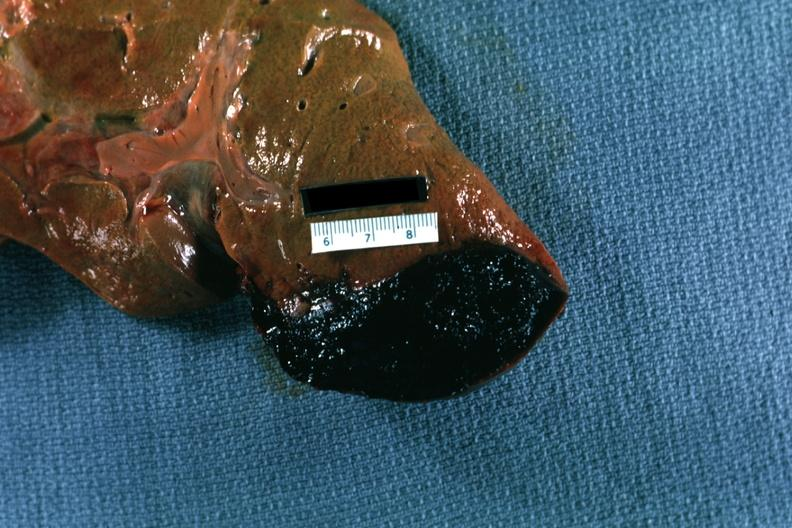what is present?
Answer the question using a single word or phrase. Liver 